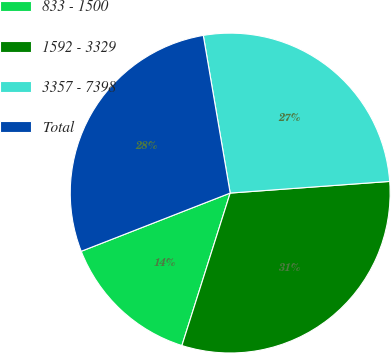Convert chart to OTSL. <chart><loc_0><loc_0><loc_500><loc_500><pie_chart><fcel>833 - 1500<fcel>1592 - 3329<fcel>3357 - 7398<fcel>Total<nl><fcel>14.19%<fcel>31.04%<fcel>26.53%<fcel>28.24%<nl></chart> 